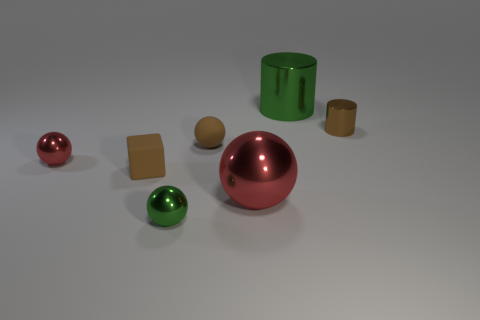What number of tiny matte objects have the same color as the cube?
Offer a terse response. 1. The object that is both right of the small brown sphere and to the left of the green cylinder is made of what material?
Your answer should be very brief. Metal. There is a thing left of the brown rubber block; does it have the same color as the big metallic object that is in front of the big green shiny thing?
Your response must be concise. Yes. How many green objects are rubber blocks or metal spheres?
Make the answer very short. 1. Are there fewer brown rubber spheres on the left side of the big red metallic ball than tiny rubber objects in front of the large green object?
Your response must be concise. Yes. Is there a brown rubber block that has the same size as the brown cylinder?
Ensure brevity in your answer.  Yes. Is the size of the metal cylinder that is to the right of the green cylinder the same as the big ball?
Keep it short and to the point. No. Are there more green objects than big red matte spheres?
Provide a short and direct response. Yes. Is there a brown shiny thing that has the same shape as the large green object?
Offer a terse response. Yes. What is the shape of the small brown matte thing in front of the matte ball?
Provide a short and direct response. Cube. 